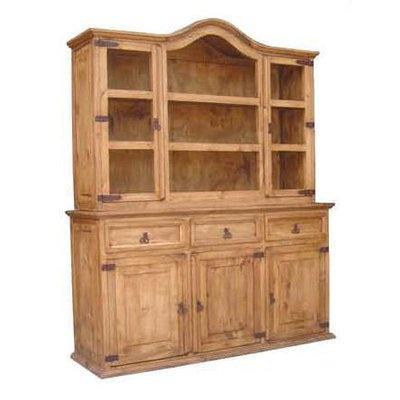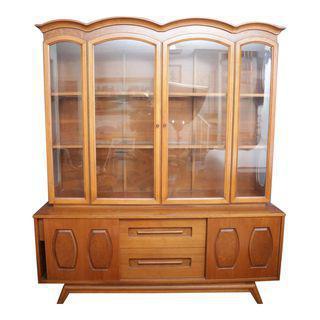The first image is the image on the left, the second image is the image on the right. Given the left and right images, does the statement "Both of the cabinets depicted have flat tops and some type of feet." hold true? Answer yes or no. No. 